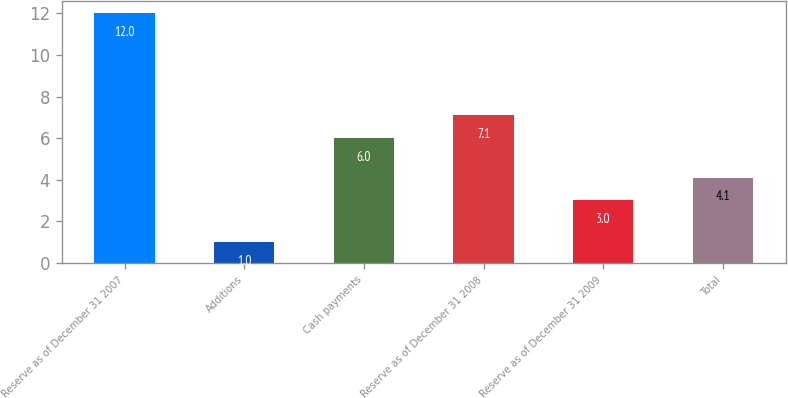Convert chart to OTSL. <chart><loc_0><loc_0><loc_500><loc_500><bar_chart><fcel>Reserve as of December 31 2007<fcel>Additions<fcel>Cash payments<fcel>Reserve as of December 31 2008<fcel>Reserve as of December 31 2009<fcel>Total<nl><fcel>12<fcel>1<fcel>6<fcel>7.1<fcel>3<fcel>4.1<nl></chart> 